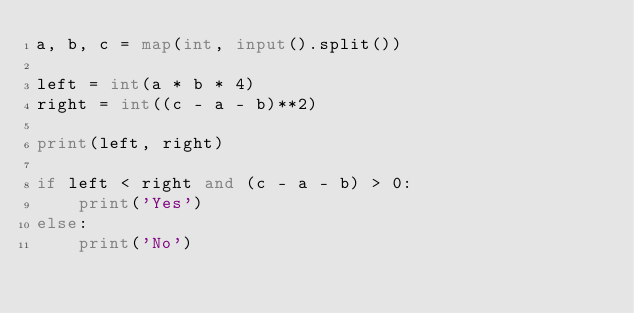Convert code to text. <code><loc_0><loc_0><loc_500><loc_500><_Python_>a, b, c = map(int, input().split())

left = int(a * b * 4)
right = int((c - a - b)**2)

print(left, right)

if left < right and (c - a - b) > 0:
    print('Yes')
else:
    print('No')</code> 